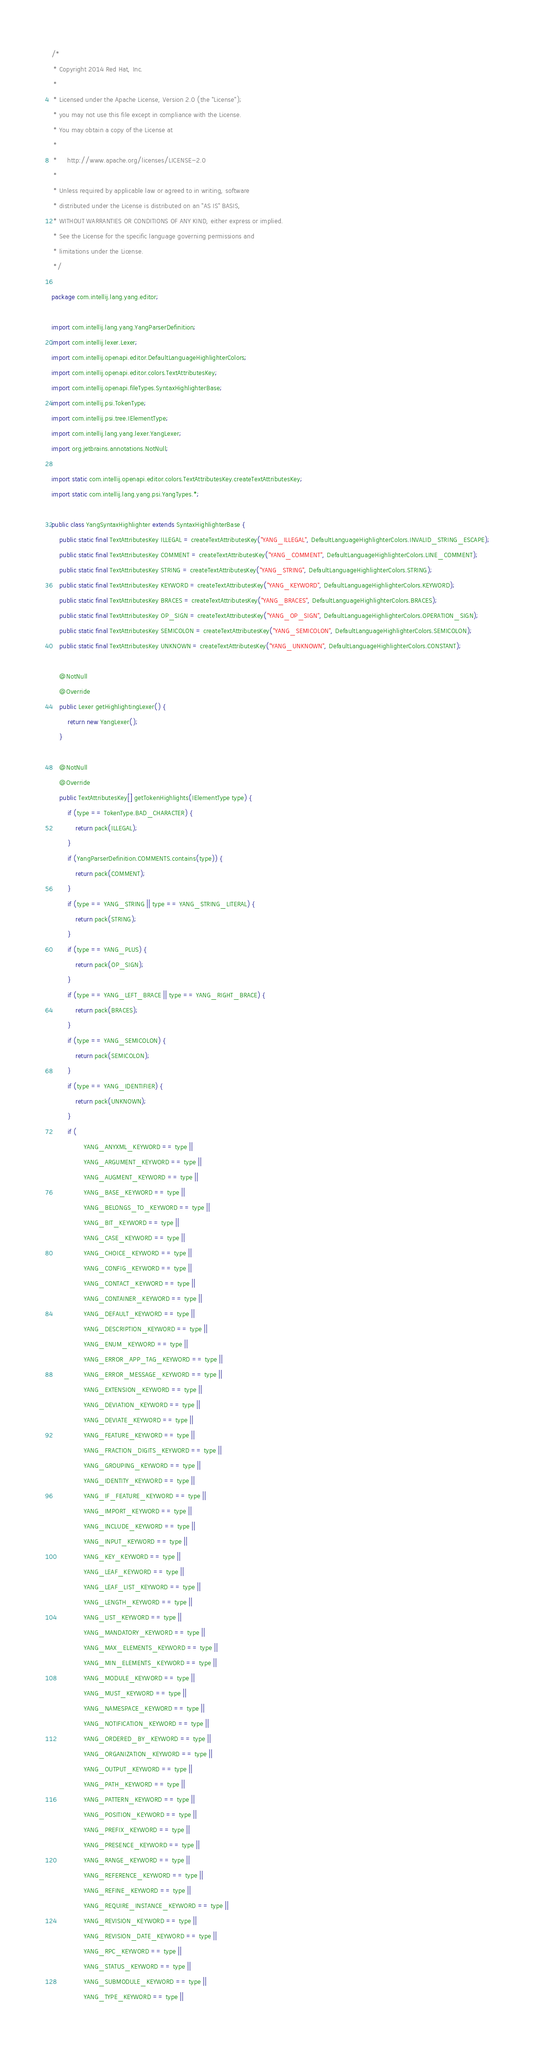<code> <loc_0><loc_0><loc_500><loc_500><_Java_>/*
 * Copyright 2014 Red Hat, Inc.
 *
 * Licensed under the Apache License, Version 2.0 (the "License");
 * you may not use this file except in compliance with the License.
 * You may obtain a copy of the License at
 *
 *     http://www.apache.org/licenses/LICENSE-2.0
 *
 * Unless required by applicable law or agreed to in writing, software
 * distributed under the License is distributed on an "AS IS" BASIS,
 * WITHOUT WARRANTIES OR CONDITIONS OF ANY KIND, either express or implied.
 * See the License for the specific language governing permissions and
 * limitations under the License.
 */

package com.intellij.lang.yang.editor;

import com.intellij.lang.yang.YangParserDefinition;
import com.intellij.lexer.Lexer;
import com.intellij.openapi.editor.DefaultLanguageHighlighterColors;
import com.intellij.openapi.editor.colors.TextAttributesKey;
import com.intellij.openapi.fileTypes.SyntaxHighlighterBase;
import com.intellij.psi.TokenType;
import com.intellij.psi.tree.IElementType;
import com.intellij.lang.yang.lexer.YangLexer;
import org.jetbrains.annotations.NotNull;

import static com.intellij.openapi.editor.colors.TextAttributesKey.createTextAttributesKey;
import static com.intellij.lang.yang.psi.YangTypes.*;

public class YangSyntaxHighlighter extends SyntaxHighlighterBase {
    public static final TextAttributesKey ILLEGAL = createTextAttributesKey("YANG_ILLEGAL", DefaultLanguageHighlighterColors.INVALID_STRING_ESCAPE);
    public static final TextAttributesKey COMMENT = createTextAttributesKey("YANG_COMMENT", DefaultLanguageHighlighterColors.LINE_COMMENT);
    public static final TextAttributesKey STRING = createTextAttributesKey("YANG_STRING", DefaultLanguageHighlighterColors.STRING);
    public static final TextAttributesKey KEYWORD = createTextAttributesKey("YANG_KEYWORD", DefaultLanguageHighlighterColors.KEYWORD);
    public static final TextAttributesKey BRACES = createTextAttributesKey("YANG_BRACES", DefaultLanguageHighlighterColors.BRACES);
    public static final TextAttributesKey OP_SIGN = createTextAttributesKey("YANG_OP_SIGN", DefaultLanguageHighlighterColors.OPERATION_SIGN);
    public static final TextAttributesKey SEMICOLON = createTextAttributesKey("YANG_SEMICOLON", DefaultLanguageHighlighterColors.SEMICOLON);
    public static final TextAttributesKey UNKNOWN = createTextAttributesKey("YANG_UNKNOWN", DefaultLanguageHighlighterColors.CONSTANT);

    @NotNull
    @Override
    public Lexer getHighlightingLexer() {
        return new YangLexer();
    }

    @NotNull
    @Override
    public TextAttributesKey[] getTokenHighlights(IElementType type) {
        if (type == TokenType.BAD_CHARACTER) {
            return pack(ILLEGAL);
        }
        if (YangParserDefinition.COMMENTS.contains(type)) {
            return pack(COMMENT);
        }
        if (type == YANG_STRING || type == YANG_STRING_LITERAL) {
            return pack(STRING);
        }
        if (type == YANG_PLUS) {
            return pack(OP_SIGN);
        }
        if (type == YANG_LEFT_BRACE || type == YANG_RIGHT_BRACE) {
            return pack(BRACES);
        }
        if (type == YANG_SEMICOLON) {
            return pack(SEMICOLON);
        }
        if (type == YANG_IDENTIFIER) {
            return pack(UNKNOWN);
        }
        if (
                YANG_ANYXML_KEYWORD == type ||
                YANG_ARGUMENT_KEYWORD == type ||
                YANG_AUGMENT_KEYWORD == type ||
                YANG_BASE_KEYWORD == type ||
                YANG_BELONGS_TO_KEYWORD == type ||
                YANG_BIT_KEYWORD == type ||
                YANG_CASE_KEYWORD == type ||
                YANG_CHOICE_KEYWORD == type ||
                YANG_CONFIG_KEYWORD == type ||
                YANG_CONTACT_KEYWORD == type ||
                YANG_CONTAINER_KEYWORD == type ||
                YANG_DEFAULT_KEYWORD == type ||
                YANG_DESCRIPTION_KEYWORD == type ||
                YANG_ENUM_KEYWORD == type ||
                YANG_ERROR_APP_TAG_KEYWORD == type ||
                YANG_ERROR_MESSAGE_KEYWORD == type ||
                YANG_EXTENSION_KEYWORD == type ||
                YANG_DEVIATION_KEYWORD == type ||
                YANG_DEVIATE_KEYWORD == type ||
                YANG_FEATURE_KEYWORD == type ||
                YANG_FRACTION_DIGITS_KEYWORD == type ||
                YANG_GROUPING_KEYWORD == type ||
                YANG_IDENTITY_KEYWORD == type ||
                YANG_IF_FEATURE_KEYWORD == type ||
                YANG_IMPORT_KEYWORD == type ||
                YANG_INCLUDE_KEYWORD == type ||
                YANG_INPUT_KEYWORD == type ||
                YANG_KEY_KEYWORD == type ||
                YANG_LEAF_KEYWORD == type ||
                YANG_LEAF_LIST_KEYWORD == type ||
                YANG_LENGTH_KEYWORD == type ||
                YANG_LIST_KEYWORD == type ||
                YANG_MANDATORY_KEYWORD == type ||
                YANG_MAX_ELEMENTS_KEYWORD == type ||
                YANG_MIN_ELEMENTS_KEYWORD == type ||
                YANG_MODULE_KEYWORD == type ||
                YANG_MUST_KEYWORD == type ||
                YANG_NAMESPACE_KEYWORD == type ||
                YANG_NOTIFICATION_KEYWORD == type ||
                YANG_ORDERED_BY_KEYWORD == type ||
                YANG_ORGANIZATION_KEYWORD == type ||
                YANG_OUTPUT_KEYWORD == type ||
                YANG_PATH_KEYWORD == type ||
                YANG_PATTERN_KEYWORD == type ||
                YANG_POSITION_KEYWORD == type ||
                YANG_PREFIX_KEYWORD == type ||
                YANG_PRESENCE_KEYWORD == type ||
                YANG_RANGE_KEYWORD == type ||
                YANG_REFERENCE_KEYWORD == type ||
                YANG_REFINE_KEYWORD == type ||
                YANG_REQUIRE_INSTANCE_KEYWORD == type ||
                YANG_REVISION_KEYWORD == type ||
                YANG_REVISION_DATE_KEYWORD == type ||
                YANG_RPC_KEYWORD == type ||
                YANG_STATUS_KEYWORD == type ||
                YANG_SUBMODULE_KEYWORD == type ||
                YANG_TYPE_KEYWORD == type ||</code> 